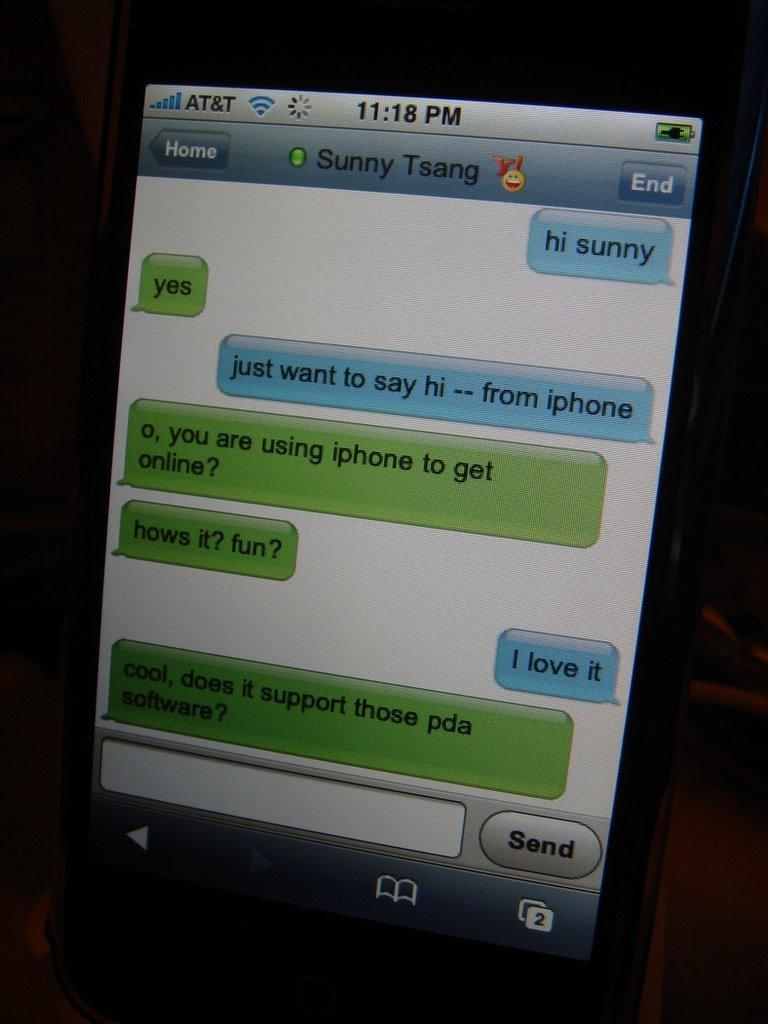<image>
Present a compact description of the photo's key features. A display shows texts from Sunny Tsang at 11:18 pm. 